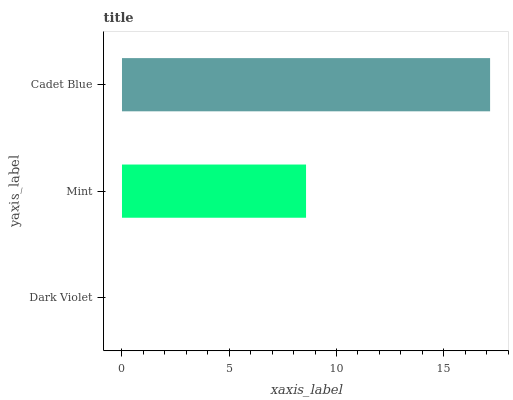Is Dark Violet the minimum?
Answer yes or no. Yes. Is Cadet Blue the maximum?
Answer yes or no. Yes. Is Mint the minimum?
Answer yes or no. No. Is Mint the maximum?
Answer yes or no. No. Is Mint greater than Dark Violet?
Answer yes or no. Yes. Is Dark Violet less than Mint?
Answer yes or no. Yes. Is Dark Violet greater than Mint?
Answer yes or no. No. Is Mint less than Dark Violet?
Answer yes or no. No. Is Mint the high median?
Answer yes or no. Yes. Is Mint the low median?
Answer yes or no. Yes. Is Dark Violet the high median?
Answer yes or no. No. Is Dark Violet the low median?
Answer yes or no. No. 